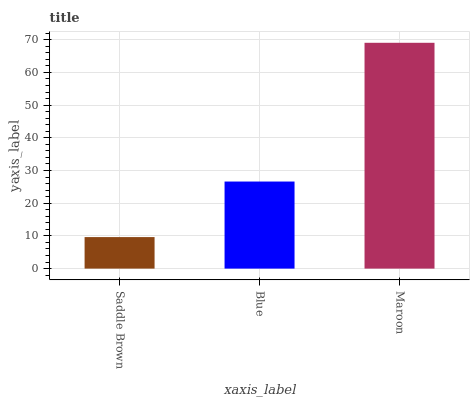Is Saddle Brown the minimum?
Answer yes or no. Yes. Is Maroon the maximum?
Answer yes or no. Yes. Is Blue the minimum?
Answer yes or no. No. Is Blue the maximum?
Answer yes or no. No. Is Blue greater than Saddle Brown?
Answer yes or no. Yes. Is Saddle Brown less than Blue?
Answer yes or no. Yes. Is Saddle Brown greater than Blue?
Answer yes or no. No. Is Blue less than Saddle Brown?
Answer yes or no. No. Is Blue the high median?
Answer yes or no. Yes. Is Blue the low median?
Answer yes or no. Yes. Is Saddle Brown the high median?
Answer yes or no. No. Is Maroon the low median?
Answer yes or no. No. 